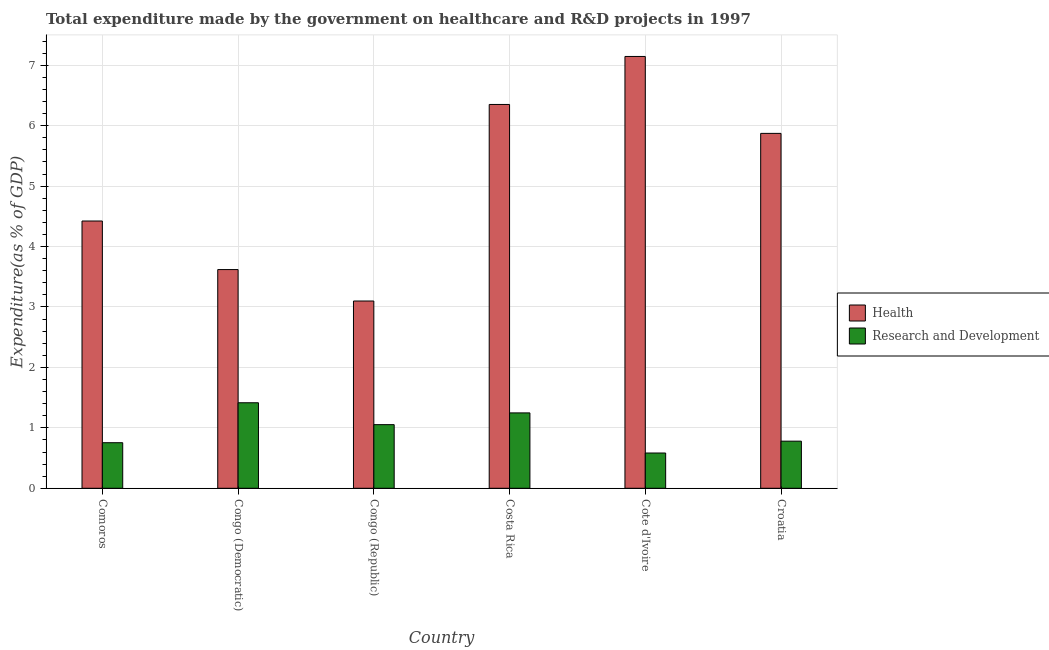How many groups of bars are there?
Your answer should be compact. 6. Are the number of bars per tick equal to the number of legend labels?
Provide a short and direct response. Yes. How many bars are there on the 1st tick from the left?
Provide a short and direct response. 2. What is the label of the 6th group of bars from the left?
Your answer should be very brief. Croatia. What is the expenditure in r&d in Cote d'Ivoire?
Provide a short and direct response. 0.58. Across all countries, what is the maximum expenditure in r&d?
Your answer should be compact. 1.42. Across all countries, what is the minimum expenditure in r&d?
Your answer should be very brief. 0.58. In which country was the expenditure in r&d maximum?
Offer a very short reply. Congo (Democratic). In which country was the expenditure in healthcare minimum?
Your answer should be compact. Congo (Republic). What is the total expenditure in healthcare in the graph?
Make the answer very short. 30.51. What is the difference between the expenditure in r&d in Congo (Republic) and that in Costa Rica?
Give a very brief answer. -0.19. What is the difference between the expenditure in healthcare in Costa Rica and the expenditure in r&d in Congo (Democratic)?
Provide a short and direct response. 4.94. What is the average expenditure in healthcare per country?
Your answer should be compact. 5.08. What is the difference between the expenditure in r&d and expenditure in healthcare in Congo (Democratic)?
Your answer should be compact. -2.2. What is the ratio of the expenditure in r&d in Congo (Democratic) to that in Costa Rica?
Offer a terse response. 1.13. Is the difference between the expenditure in healthcare in Congo (Democratic) and Costa Rica greater than the difference between the expenditure in r&d in Congo (Democratic) and Costa Rica?
Offer a very short reply. No. What is the difference between the highest and the second highest expenditure in healthcare?
Provide a succinct answer. 0.79. What is the difference between the highest and the lowest expenditure in healthcare?
Ensure brevity in your answer.  4.05. Is the sum of the expenditure in healthcare in Congo (Democratic) and Costa Rica greater than the maximum expenditure in r&d across all countries?
Keep it short and to the point. Yes. What does the 2nd bar from the left in Costa Rica represents?
Make the answer very short. Research and Development. What does the 1st bar from the right in Congo (Republic) represents?
Your answer should be compact. Research and Development. How many bars are there?
Provide a short and direct response. 12. Are all the bars in the graph horizontal?
Ensure brevity in your answer.  No. What is the difference between two consecutive major ticks on the Y-axis?
Make the answer very short. 1. Where does the legend appear in the graph?
Ensure brevity in your answer.  Center right. How are the legend labels stacked?
Offer a very short reply. Vertical. What is the title of the graph?
Your answer should be very brief. Total expenditure made by the government on healthcare and R&D projects in 1997. What is the label or title of the X-axis?
Your answer should be compact. Country. What is the label or title of the Y-axis?
Give a very brief answer. Expenditure(as % of GDP). What is the Expenditure(as % of GDP) in Health in Comoros?
Give a very brief answer. 4.42. What is the Expenditure(as % of GDP) of Research and Development in Comoros?
Provide a succinct answer. 0.75. What is the Expenditure(as % of GDP) in Health in Congo (Democratic)?
Provide a succinct answer. 3.62. What is the Expenditure(as % of GDP) of Research and Development in Congo (Democratic)?
Offer a very short reply. 1.42. What is the Expenditure(as % of GDP) of Health in Congo (Republic)?
Provide a short and direct response. 3.1. What is the Expenditure(as % of GDP) in Research and Development in Congo (Republic)?
Your response must be concise. 1.05. What is the Expenditure(as % of GDP) of Health in Costa Rica?
Give a very brief answer. 6.35. What is the Expenditure(as % of GDP) of Research and Development in Costa Rica?
Your answer should be compact. 1.25. What is the Expenditure(as % of GDP) in Health in Cote d'Ivoire?
Offer a very short reply. 7.14. What is the Expenditure(as % of GDP) of Research and Development in Cote d'Ivoire?
Offer a very short reply. 0.58. What is the Expenditure(as % of GDP) of Health in Croatia?
Offer a terse response. 5.87. What is the Expenditure(as % of GDP) in Research and Development in Croatia?
Your answer should be compact. 0.78. Across all countries, what is the maximum Expenditure(as % of GDP) in Health?
Your answer should be very brief. 7.14. Across all countries, what is the maximum Expenditure(as % of GDP) of Research and Development?
Make the answer very short. 1.42. Across all countries, what is the minimum Expenditure(as % of GDP) in Health?
Your answer should be compact. 3.1. Across all countries, what is the minimum Expenditure(as % of GDP) of Research and Development?
Your answer should be very brief. 0.58. What is the total Expenditure(as % of GDP) in Health in the graph?
Provide a short and direct response. 30.51. What is the total Expenditure(as % of GDP) in Research and Development in the graph?
Offer a terse response. 5.83. What is the difference between the Expenditure(as % of GDP) in Health in Comoros and that in Congo (Democratic)?
Your response must be concise. 0.8. What is the difference between the Expenditure(as % of GDP) of Research and Development in Comoros and that in Congo (Democratic)?
Make the answer very short. -0.66. What is the difference between the Expenditure(as % of GDP) of Health in Comoros and that in Congo (Republic)?
Provide a short and direct response. 1.32. What is the difference between the Expenditure(as % of GDP) in Research and Development in Comoros and that in Congo (Republic)?
Your answer should be compact. -0.3. What is the difference between the Expenditure(as % of GDP) of Health in Comoros and that in Costa Rica?
Keep it short and to the point. -1.93. What is the difference between the Expenditure(as % of GDP) of Research and Development in Comoros and that in Costa Rica?
Keep it short and to the point. -0.49. What is the difference between the Expenditure(as % of GDP) in Health in Comoros and that in Cote d'Ivoire?
Give a very brief answer. -2.72. What is the difference between the Expenditure(as % of GDP) in Research and Development in Comoros and that in Cote d'Ivoire?
Your answer should be very brief. 0.17. What is the difference between the Expenditure(as % of GDP) of Health in Comoros and that in Croatia?
Your answer should be very brief. -1.45. What is the difference between the Expenditure(as % of GDP) of Research and Development in Comoros and that in Croatia?
Offer a terse response. -0.03. What is the difference between the Expenditure(as % of GDP) in Health in Congo (Democratic) and that in Congo (Republic)?
Ensure brevity in your answer.  0.52. What is the difference between the Expenditure(as % of GDP) of Research and Development in Congo (Democratic) and that in Congo (Republic)?
Ensure brevity in your answer.  0.36. What is the difference between the Expenditure(as % of GDP) in Health in Congo (Democratic) and that in Costa Rica?
Offer a very short reply. -2.73. What is the difference between the Expenditure(as % of GDP) of Research and Development in Congo (Democratic) and that in Costa Rica?
Make the answer very short. 0.17. What is the difference between the Expenditure(as % of GDP) in Health in Congo (Democratic) and that in Cote d'Ivoire?
Your answer should be very brief. -3.53. What is the difference between the Expenditure(as % of GDP) in Research and Development in Congo (Democratic) and that in Cote d'Ivoire?
Provide a succinct answer. 0.83. What is the difference between the Expenditure(as % of GDP) in Health in Congo (Democratic) and that in Croatia?
Provide a short and direct response. -2.25. What is the difference between the Expenditure(as % of GDP) of Research and Development in Congo (Democratic) and that in Croatia?
Provide a succinct answer. 0.64. What is the difference between the Expenditure(as % of GDP) in Health in Congo (Republic) and that in Costa Rica?
Offer a terse response. -3.25. What is the difference between the Expenditure(as % of GDP) of Research and Development in Congo (Republic) and that in Costa Rica?
Provide a short and direct response. -0.19. What is the difference between the Expenditure(as % of GDP) of Health in Congo (Republic) and that in Cote d'Ivoire?
Your answer should be very brief. -4.05. What is the difference between the Expenditure(as % of GDP) in Research and Development in Congo (Republic) and that in Cote d'Ivoire?
Ensure brevity in your answer.  0.47. What is the difference between the Expenditure(as % of GDP) of Health in Congo (Republic) and that in Croatia?
Your response must be concise. -2.77. What is the difference between the Expenditure(as % of GDP) in Research and Development in Congo (Republic) and that in Croatia?
Provide a short and direct response. 0.27. What is the difference between the Expenditure(as % of GDP) of Health in Costa Rica and that in Cote d'Ivoire?
Your answer should be very brief. -0.79. What is the difference between the Expenditure(as % of GDP) of Research and Development in Costa Rica and that in Cote d'Ivoire?
Offer a very short reply. 0.66. What is the difference between the Expenditure(as % of GDP) in Health in Costa Rica and that in Croatia?
Your answer should be compact. 0.48. What is the difference between the Expenditure(as % of GDP) in Research and Development in Costa Rica and that in Croatia?
Ensure brevity in your answer.  0.47. What is the difference between the Expenditure(as % of GDP) in Health in Cote d'Ivoire and that in Croatia?
Give a very brief answer. 1.27. What is the difference between the Expenditure(as % of GDP) of Research and Development in Cote d'Ivoire and that in Croatia?
Offer a terse response. -0.2. What is the difference between the Expenditure(as % of GDP) of Health in Comoros and the Expenditure(as % of GDP) of Research and Development in Congo (Democratic)?
Offer a very short reply. 3.01. What is the difference between the Expenditure(as % of GDP) in Health in Comoros and the Expenditure(as % of GDP) in Research and Development in Congo (Republic)?
Your answer should be very brief. 3.37. What is the difference between the Expenditure(as % of GDP) in Health in Comoros and the Expenditure(as % of GDP) in Research and Development in Costa Rica?
Offer a very short reply. 3.18. What is the difference between the Expenditure(as % of GDP) of Health in Comoros and the Expenditure(as % of GDP) of Research and Development in Cote d'Ivoire?
Give a very brief answer. 3.84. What is the difference between the Expenditure(as % of GDP) in Health in Comoros and the Expenditure(as % of GDP) in Research and Development in Croatia?
Provide a succinct answer. 3.64. What is the difference between the Expenditure(as % of GDP) in Health in Congo (Democratic) and the Expenditure(as % of GDP) in Research and Development in Congo (Republic)?
Provide a succinct answer. 2.57. What is the difference between the Expenditure(as % of GDP) in Health in Congo (Democratic) and the Expenditure(as % of GDP) in Research and Development in Costa Rica?
Ensure brevity in your answer.  2.37. What is the difference between the Expenditure(as % of GDP) in Health in Congo (Democratic) and the Expenditure(as % of GDP) in Research and Development in Cote d'Ivoire?
Give a very brief answer. 3.04. What is the difference between the Expenditure(as % of GDP) in Health in Congo (Democratic) and the Expenditure(as % of GDP) in Research and Development in Croatia?
Offer a terse response. 2.84. What is the difference between the Expenditure(as % of GDP) in Health in Congo (Republic) and the Expenditure(as % of GDP) in Research and Development in Costa Rica?
Offer a very short reply. 1.85. What is the difference between the Expenditure(as % of GDP) in Health in Congo (Republic) and the Expenditure(as % of GDP) in Research and Development in Cote d'Ivoire?
Your answer should be very brief. 2.52. What is the difference between the Expenditure(as % of GDP) of Health in Congo (Republic) and the Expenditure(as % of GDP) of Research and Development in Croatia?
Offer a very short reply. 2.32. What is the difference between the Expenditure(as % of GDP) in Health in Costa Rica and the Expenditure(as % of GDP) in Research and Development in Cote d'Ivoire?
Your response must be concise. 5.77. What is the difference between the Expenditure(as % of GDP) of Health in Costa Rica and the Expenditure(as % of GDP) of Research and Development in Croatia?
Your answer should be compact. 5.57. What is the difference between the Expenditure(as % of GDP) of Health in Cote d'Ivoire and the Expenditure(as % of GDP) of Research and Development in Croatia?
Provide a succinct answer. 6.37. What is the average Expenditure(as % of GDP) in Health per country?
Provide a succinct answer. 5.08. What is the average Expenditure(as % of GDP) of Research and Development per country?
Ensure brevity in your answer.  0.97. What is the difference between the Expenditure(as % of GDP) of Health and Expenditure(as % of GDP) of Research and Development in Comoros?
Make the answer very short. 3.67. What is the difference between the Expenditure(as % of GDP) of Health and Expenditure(as % of GDP) of Research and Development in Congo (Democratic)?
Provide a short and direct response. 2.2. What is the difference between the Expenditure(as % of GDP) in Health and Expenditure(as % of GDP) in Research and Development in Congo (Republic)?
Your answer should be very brief. 2.05. What is the difference between the Expenditure(as % of GDP) in Health and Expenditure(as % of GDP) in Research and Development in Costa Rica?
Provide a short and direct response. 5.1. What is the difference between the Expenditure(as % of GDP) in Health and Expenditure(as % of GDP) in Research and Development in Cote d'Ivoire?
Make the answer very short. 6.56. What is the difference between the Expenditure(as % of GDP) in Health and Expenditure(as % of GDP) in Research and Development in Croatia?
Your answer should be compact. 5.09. What is the ratio of the Expenditure(as % of GDP) in Health in Comoros to that in Congo (Democratic)?
Your response must be concise. 1.22. What is the ratio of the Expenditure(as % of GDP) in Research and Development in Comoros to that in Congo (Democratic)?
Provide a succinct answer. 0.53. What is the ratio of the Expenditure(as % of GDP) in Health in Comoros to that in Congo (Republic)?
Ensure brevity in your answer.  1.43. What is the ratio of the Expenditure(as % of GDP) of Research and Development in Comoros to that in Congo (Republic)?
Offer a terse response. 0.72. What is the ratio of the Expenditure(as % of GDP) of Health in Comoros to that in Costa Rica?
Offer a terse response. 0.7. What is the ratio of the Expenditure(as % of GDP) in Research and Development in Comoros to that in Costa Rica?
Your answer should be very brief. 0.6. What is the ratio of the Expenditure(as % of GDP) of Health in Comoros to that in Cote d'Ivoire?
Your response must be concise. 0.62. What is the ratio of the Expenditure(as % of GDP) of Research and Development in Comoros to that in Cote d'Ivoire?
Provide a short and direct response. 1.29. What is the ratio of the Expenditure(as % of GDP) of Health in Comoros to that in Croatia?
Ensure brevity in your answer.  0.75. What is the ratio of the Expenditure(as % of GDP) of Research and Development in Comoros to that in Croatia?
Keep it short and to the point. 0.97. What is the ratio of the Expenditure(as % of GDP) in Health in Congo (Democratic) to that in Congo (Republic)?
Keep it short and to the point. 1.17. What is the ratio of the Expenditure(as % of GDP) of Research and Development in Congo (Democratic) to that in Congo (Republic)?
Your response must be concise. 1.34. What is the ratio of the Expenditure(as % of GDP) of Health in Congo (Democratic) to that in Costa Rica?
Keep it short and to the point. 0.57. What is the ratio of the Expenditure(as % of GDP) in Research and Development in Congo (Democratic) to that in Costa Rica?
Give a very brief answer. 1.13. What is the ratio of the Expenditure(as % of GDP) of Health in Congo (Democratic) to that in Cote d'Ivoire?
Provide a short and direct response. 0.51. What is the ratio of the Expenditure(as % of GDP) of Research and Development in Congo (Democratic) to that in Cote d'Ivoire?
Your response must be concise. 2.42. What is the ratio of the Expenditure(as % of GDP) in Health in Congo (Democratic) to that in Croatia?
Keep it short and to the point. 0.62. What is the ratio of the Expenditure(as % of GDP) of Research and Development in Congo (Democratic) to that in Croatia?
Provide a succinct answer. 1.81. What is the ratio of the Expenditure(as % of GDP) in Health in Congo (Republic) to that in Costa Rica?
Offer a very short reply. 0.49. What is the ratio of the Expenditure(as % of GDP) of Research and Development in Congo (Republic) to that in Costa Rica?
Give a very brief answer. 0.84. What is the ratio of the Expenditure(as % of GDP) of Health in Congo (Republic) to that in Cote d'Ivoire?
Your answer should be very brief. 0.43. What is the ratio of the Expenditure(as % of GDP) in Research and Development in Congo (Republic) to that in Cote d'Ivoire?
Provide a succinct answer. 1.8. What is the ratio of the Expenditure(as % of GDP) in Health in Congo (Republic) to that in Croatia?
Offer a terse response. 0.53. What is the ratio of the Expenditure(as % of GDP) of Research and Development in Congo (Republic) to that in Croatia?
Provide a short and direct response. 1.35. What is the ratio of the Expenditure(as % of GDP) of Health in Costa Rica to that in Cote d'Ivoire?
Ensure brevity in your answer.  0.89. What is the ratio of the Expenditure(as % of GDP) of Research and Development in Costa Rica to that in Cote d'Ivoire?
Your response must be concise. 2.14. What is the ratio of the Expenditure(as % of GDP) in Health in Costa Rica to that in Croatia?
Ensure brevity in your answer.  1.08. What is the ratio of the Expenditure(as % of GDP) in Research and Development in Costa Rica to that in Croatia?
Your answer should be compact. 1.6. What is the ratio of the Expenditure(as % of GDP) in Health in Cote d'Ivoire to that in Croatia?
Give a very brief answer. 1.22. What is the ratio of the Expenditure(as % of GDP) in Research and Development in Cote d'Ivoire to that in Croatia?
Offer a very short reply. 0.75. What is the difference between the highest and the second highest Expenditure(as % of GDP) in Health?
Make the answer very short. 0.79. What is the difference between the highest and the second highest Expenditure(as % of GDP) of Research and Development?
Keep it short and to the point. 0.17. What is the difference between the highest and the lowest Expenditure(as % of GDP) in Health?
Make the answer very short. 4.05. What is the difference between the highest and the lowest Expenditure(as % of GDP) in Research and Development?
Your response must be concise. 0.83. 